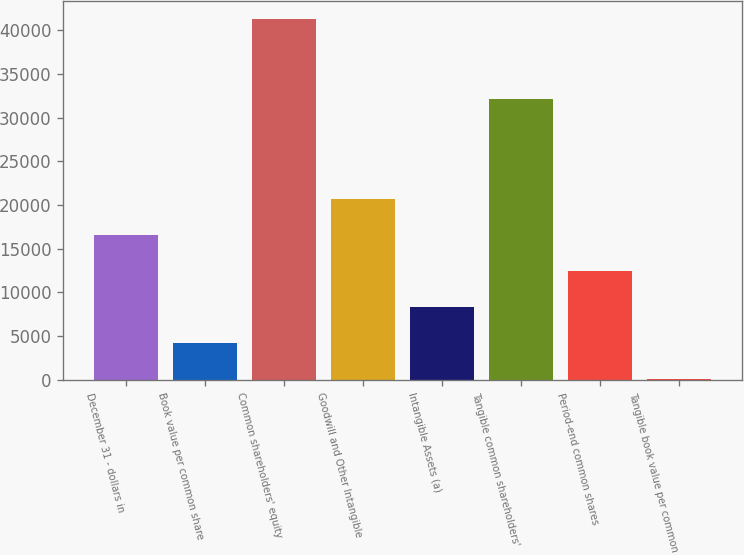<chart> <loc_0><loc_0><loc_500><loc_500><bar_chart><fcel>December 31 - dollars in<fcel>Book value per common share<fcel>Common shareholders' equity<fcel>Goodwill and Other Intangible<fcel>Intangible Assets (a)<fcel>Tangible common shareholders'<fcel>Period-end common shares<fcel>Tangible book value per common<nl><fcel>16541.4<fcel>4183.09<fcel>41258<fcel>20660.8<fcel>8302.53<fcel>32086<fcel>12422<fcel>63.65<nl></chart> 